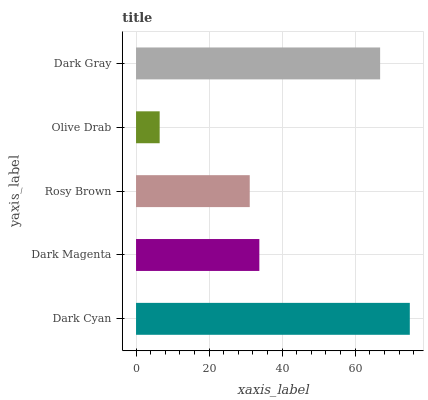Is Olive Drab the minimum?
Answer yes or no. Yes. Is Dark Cyan the maximum?
Answer yes or no. Yes. Is Dark Magenta the minimum?
Answer yes or no. No. Is Dark Magenta the maximum?
Answer yes or no. No. Is Dark Cyan greater than Dark Magenta?
Answer yes or no. Yes. Is Dark Magenta less than Dark Cyan?
Answer yes or no. Yes. Is Dark Magenta greater than Dark Cyan?
Answer yes or no. No. Is Dark Cyan less than Dark Magenta?
Answer yes or no. No. Is Dark Magenta the high median?
Answer yes or no. Yes. Is Dark Magenta the low median?
Answer yes or no. Yes. Is Dark Gray the high median?
Answer yes or no. No. Is Olive Drab the low median?
Answer yes or no. No. 